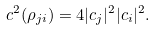<formula> <loc_0><loc_0><loc_500><loc_500>c ^ { 2 } ( \rho _ { j i } ) = 4 | c _ { j } | ^ { 2 } | c _ { i } | ^ { 2 } .</formula> 